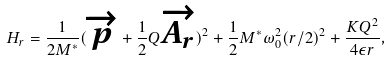Convert formula to latex. <formula><loc_0><loc_0><loc_500><loc_500>H _ { r } = \frac { 1 } { 2 M ^ { * } } ( \overrightarrow { p } + \frac { 1 } { 2 } Q \overrightarrow { A _ { r } } ) ^ { 2 } + \frac { 1 } { 2 } M ^ { * } \omega _ { 0 } ^ { 2 } { ( r / 2 ) } ^ { 2 } + \frac { K Q ^ { 2 } } { 4 \epsilon r } ,</formula> 